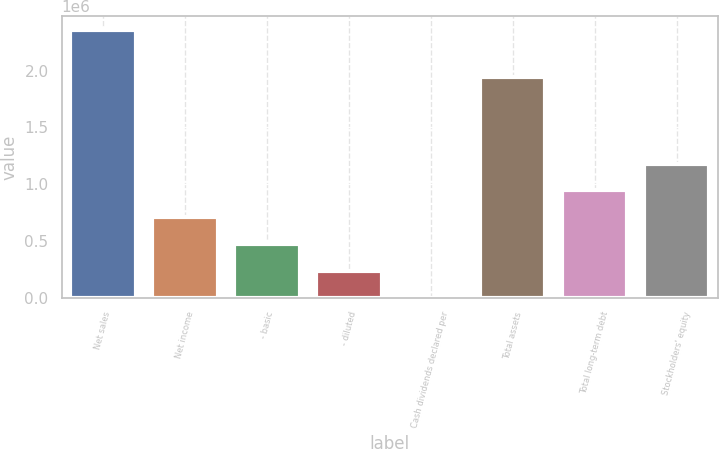<chart> <loc_0><loc_0><loc_500><loc_500><bar_chart><fcel>Net sales<fcel>Net income<fcel>- basic<fcel>- diluted<fcel>Cash dividends declared per<fcel>Total assets<fcel>Total long-term debt<fcel>Stockholders' equity<nl><fcel>2.36049e+06<fcel>708149<fcel>472100<fcel>236050<fcel>1.2<fcel>1.93974e+06<fcel>944198<fcel>1.18025e+06<nl></chart> 